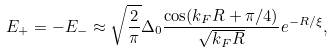Convert formula to latex. <formula><loc_0><loc_0><loc_500><loc_500>E _ { + } = - E _ { - } \approx \sqrt { \frac { 2 } { \pi } } \Delta _ { 0 } \frac { \cos ( k _ { F } R + \pi / 4 ) } { \sqrt { k _ { F } R } } e ^ { - R / \xi } ,</formula> 